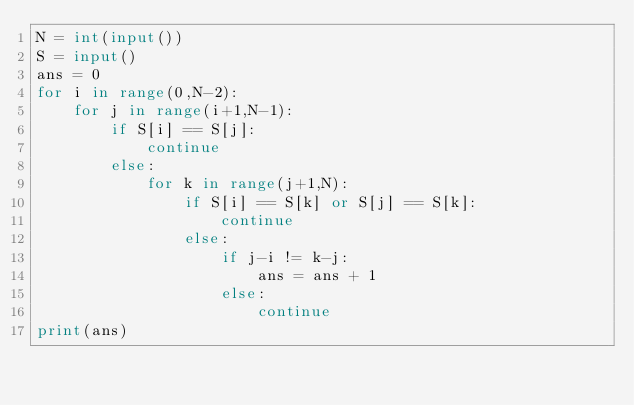<code> <loc_0><loc_0><loc_500><loc_500><_Python_>N = int(input())
S = input()
ans = 0
for i in range(0,N-2):
    for j in range(i+1,N-1):
        if S[i] == S[j]:
            continue
        else:
            for k in range(j+1,N):
                if S[i] == S[k] or S[j] == S[k]:
                    continue
                else:
                    if j-i != k-j:
                        ans = ans + 1
                    else:
                        continue
print(ans)
</code> 